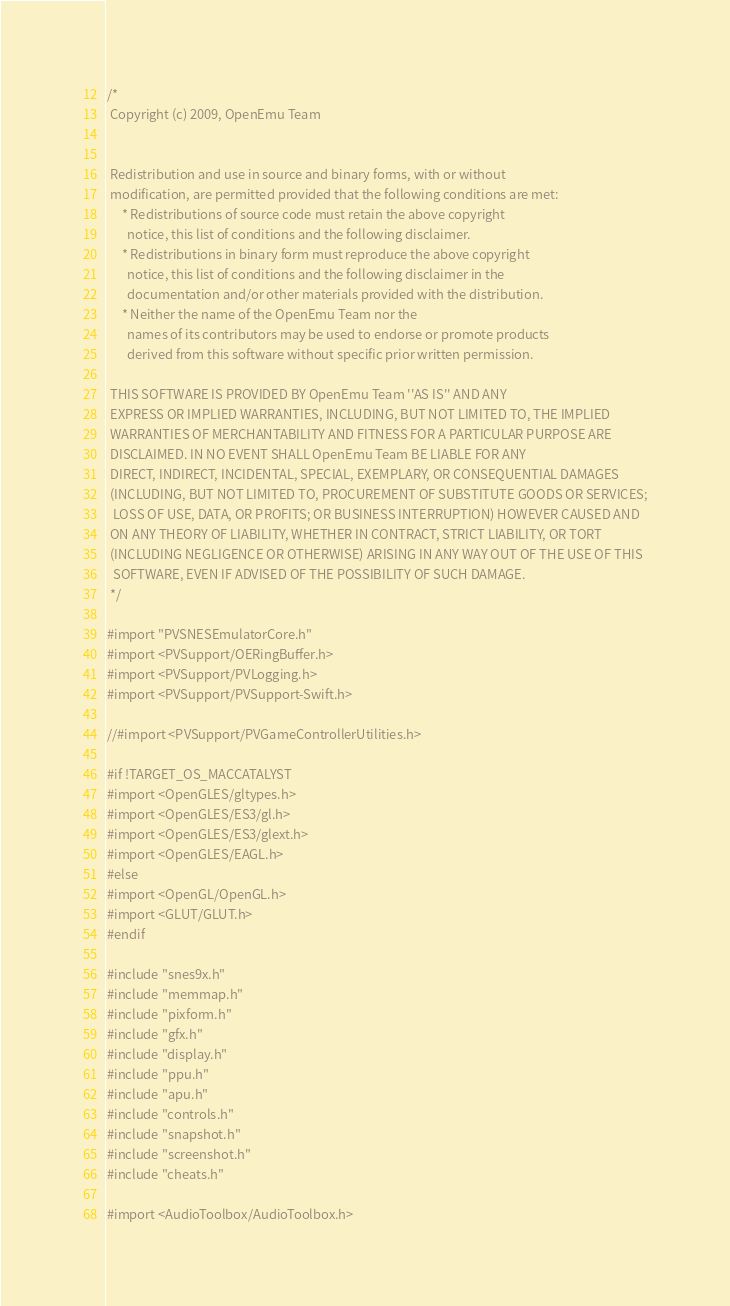<code> <loc_0><loc_0><loc_500><loc_500><_ObjectiveC_>/*
 Copyright (c) 2009, OpenEmu Team


 Redistribution and use in source and binary forms, with or without
 modification, are permitted provided that the following conditions are met:
     * Redistributions of source code must retain the above copyright
       notice, this list of conditions and the following disclaimer.
     * Redistributions in binary form must reproduce the above copyright
       notice, this list of conditions and the following disclaimer in the
       documentation and/or other materials provided with the distribution.
     * Neither the name of the OpenEmu Team nor the
       names of its contributors may be used to endorse or promote products
       derived from this software without specific prior written permission.

 THIS SOFTWARE IS PROVIDED BY OpenEmu Team ''AS IS'' AND ANY
 EXPRESS OR IMPLIED WARRANTIES, INCLUDING, BUT NOT LIMITED TO, THE IMPLIED
 WARRANTIES OF MERCHANTABILITY AND FITNESS FOR A PARTICULAR PURPOSE ARE
 DISCLAIMED. IN NO EVENT SHALL OpenEmu Team BE LIABLE FOR ANY
 DIRECT, INDIRECT, INCIDENTAL, SPECIAL, EXEMPLARY, OR CONSEQUENTIAL DAMAGES
 (INCLUDING, BUT NOT LIMITED TO, PROCUREMENT OF SUBSTITUTE GOODS OR SERVICES;
  LOSS OF USE, DATA, OR PROFITS; OR BUSINESS INTERRUPTION) HOWEVER CAUSED AND
 ON ANY THEORY OF LIABILITY, WHETHER IN CONTRACT, STRICT LIABILITY, OR TORT
 (INCLUDING NEGLIGENCE OR OTHERWISE) ARISING IN ANY WAY OUT OF THE USE OF THIS
  SOFTWARE, EVEN IF ADVISED OF THE POSSIBILITY OF SUCH DAMAGE.
 */

#import "PVSNESEmulatorCore.h"
#import <PVSupport/OERingBuffer.h>
#import <PVSupport/PVLogging.h>
#import <PVSupport/PVSupport-Swift.h>

//#import <PVSupport/PVGameControllerUtilities.h>

#if !TARGET_OS_MACCATALYST
#import <OpenGLES/gltypes.h>
#import <OpenGLES/ES3/gl.h>
#import <OpenGLES/ES3/glext.h>
#import <OpenGLES/EAGL.h>
#else
#import <OpenGL/OpenGL.h>
#import <GLUT/GLUT.h>
#endif

#include "snes9x.h"
#include "memmap.h"
#include "pixform.h"
#include "gfx.h"
#include "display.h"
#include "ppu.h"
#include "apu.h"
#include "controls.h"
#include "snapshot.h"
#include "screenshot.h"
#include "cheats.h"

#import <AudioToolbox/AudioToolbox.h></code> 